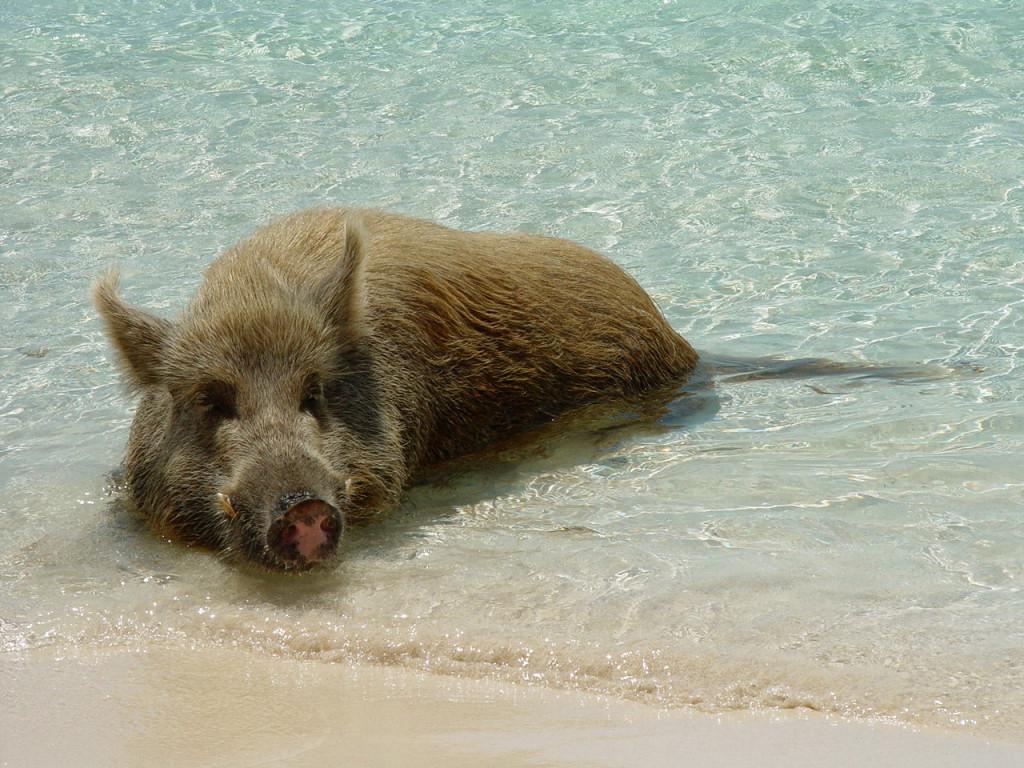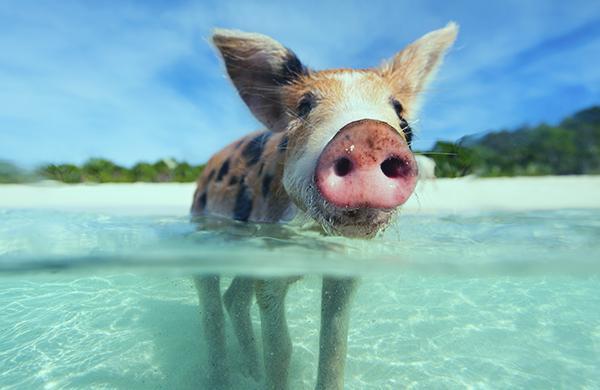The first image is the image on the left, the second image is the image on the right. Evaluate the accuracy of this statement regarding the images: "All of the hogs are in water and some of them are in crystal blue water.". Is it true? Answer yes or no. Yes. The first image is the image on the left, the second image is the image on the right. Evaluate the accuracy of this statement regarding the images: "Both images feature pigs in the water.". Is it true? Answer yes or no. Yes. 